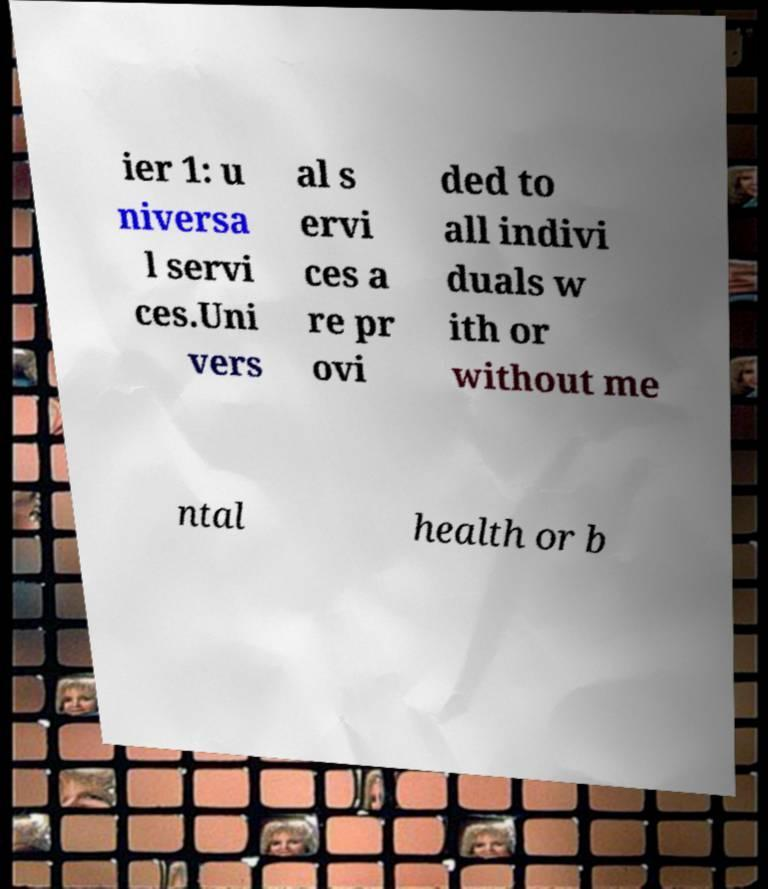Please read and relay the text visible in this image. What does it say? ier 1: u niversa l servi ces.Uni vers al s ervi ces a re pr ovi ded to all indivi duals w ith or without me ntal health or b 